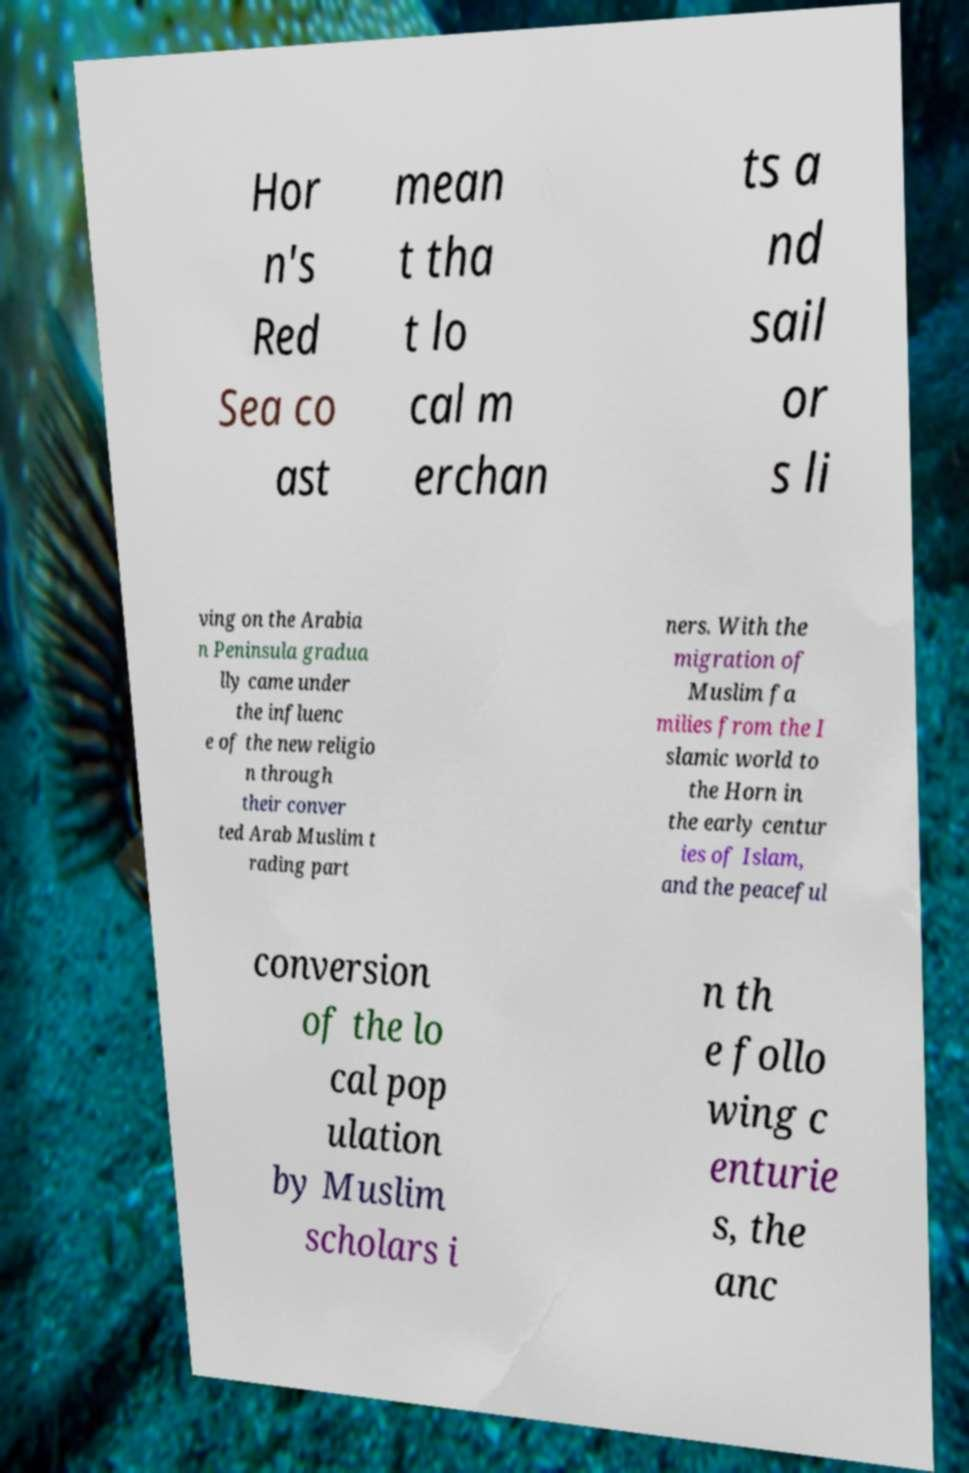What messages or text are displayed in this image? I need them in a readable, typed format. Hor n's Red Sea co ast mean t tha t lo cal m erchan ts a nd sail or s li ving on the Arabia n Peninsula gradua lly came under the influenc e of the new religio n through their conver ted Arab Muslim t rading part ners. With the migration of Muslim fa milies from the I slamic world to the Horn in the early centur ies of Islam, and the peaceful conversion of the lo cal pop ulation by Muslim scholars i n th e follo wing c enturie s, the anc 